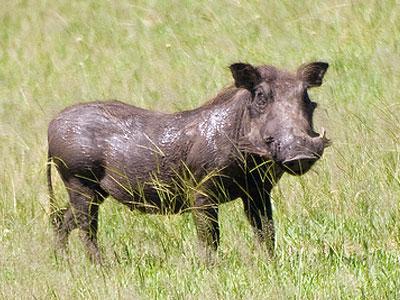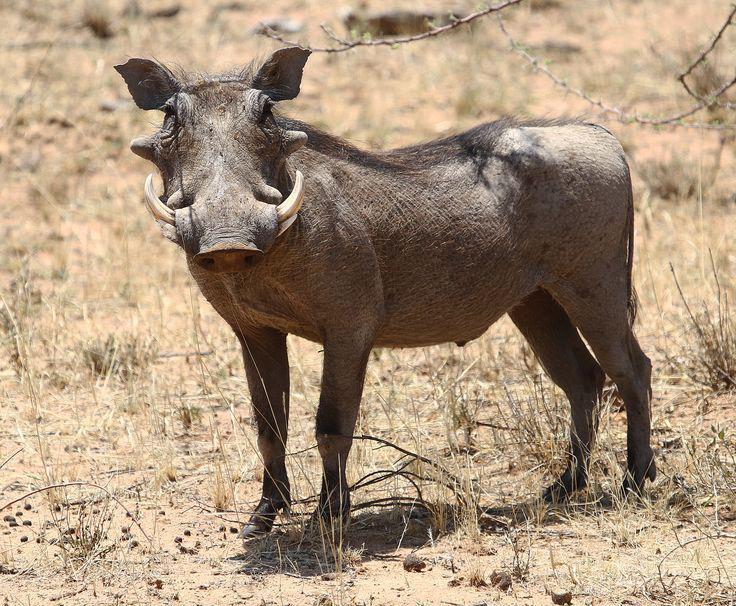The first image is the image on the left, the second image is the image on the right. Evaluate the accuracy of this statement regarding the images: "There are more than two animals total.". Is it true? Answer yes or no. No. 